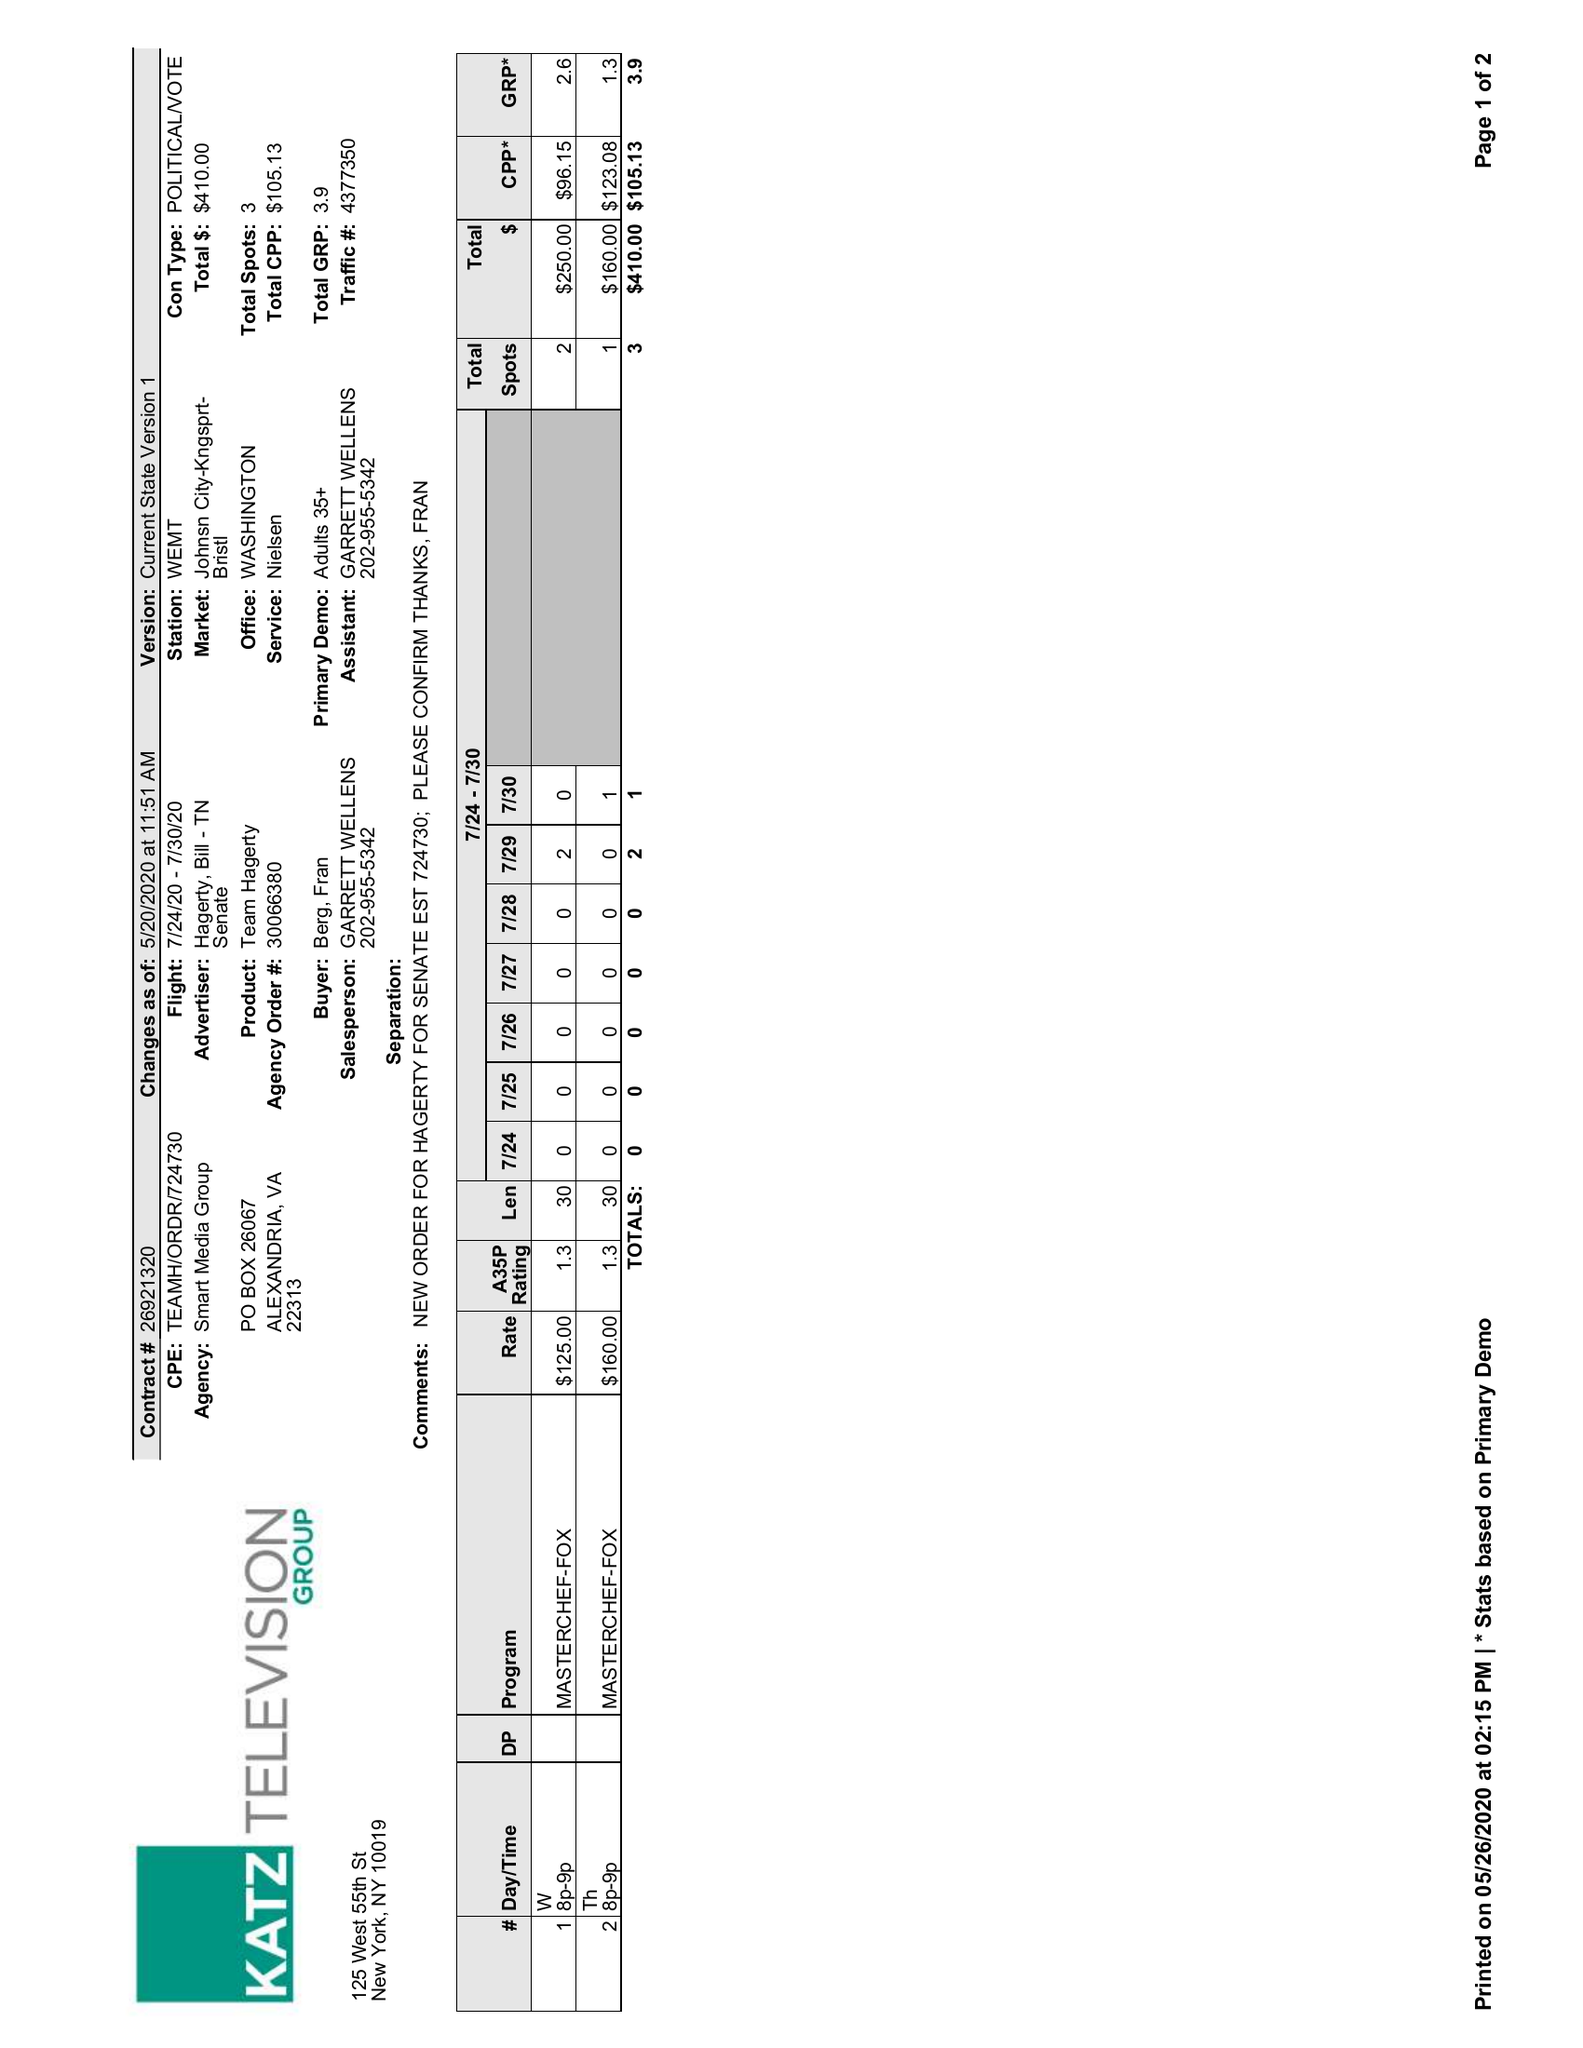What is the value for the flight_to?
Answer the question using a single word or phrase. 07/30/20 